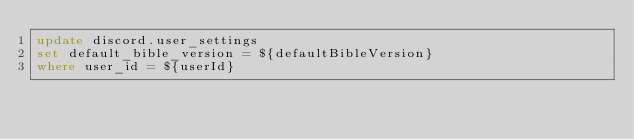Convert code to text. <code><loc_0><loc_0><loc_500><loc_500><_SQL_>update discord.user_settings
set default_bible_version = ${defaultBibleVersion}
where user_id = ${userId}</code> 